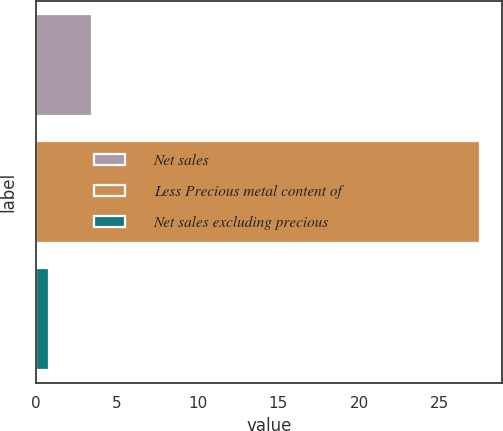Convert chart to OTSL. <chart><loc_0><loc_0><loc_500><loc_500><bar_chart><fcel>Net sales<fcel>Less Precious metal content of<fcel>Net sales excluding precious<nl><fcel>3.47<fcel>27.5<fcel>0.8<nl></chart> 